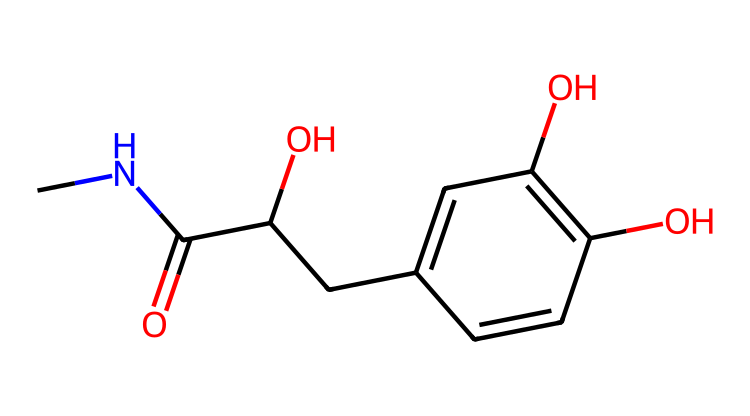What is the molecular formula of epinephrine? The molecular formula can be derived from the chemical structure by counting the number of carbon (C), hydrogen (H), nitrogen (N), and oxygen (O) atoms in the structure. There are 9 carbons, 13 hydrogens, 1 nitrogen, and 3 oxygens. Thus, the molecular formula is C9H13N3O3.
Answer: C9H13N3O3 How many hydroxyl (-OH) groups are present in epinephrine? The chemical structure shows two -OH groups attached to the aromatic ring, which can be identified by looking for hydroxyl groups directly connected to carbon atoms that are not part of a carbonyl or other functional group.
Answer: 2 What type of amine is present in epinephrine? The molecule features a primary amine because the nitrogen atom is directly attached to one carbon chain and has two hydrogen atoms, indicating that it is not bonded to multiple carbon atoms.
Answer: primary amine What functional groups are identified in epinephrine? The structure shows multiple functional groups: specifically, hydroxyl (-OH) groups and an amine group (-NH2). To identify these, one looks for the presence of oxygen and nitrogen within the framework of the molecule.
Answer: hydroxyl and amine What is the significance of the catechol structure in epinephrine? The catechol structure consists of two hydroxyl groups on a benzene ring, which contributes to the molecule's reactivity and its function as a neurotransmitter. This can be seen by analyzing the positioning of the hydroxyl groups relative to the benzene ring in the structure.
Answer: reactivity as neurotransmitter How many chiral centers does epinephrine have? A chiral center occurs at a carbon atom that is bonded to four different groups; upon examining the structure, there is one chiral carbon in epinephrine, indicating asymmetry in the molecule.
Answer: 1 What role does epinephrine play in the human body? Epinephrine is known as an adrenergic hormone that plays a vital role in the fight-or-flight response, especially in situations of stress or danger, thus it can be linked to physiological responses such as increased heart rate and blood glucose levels.
Answer: stress response 